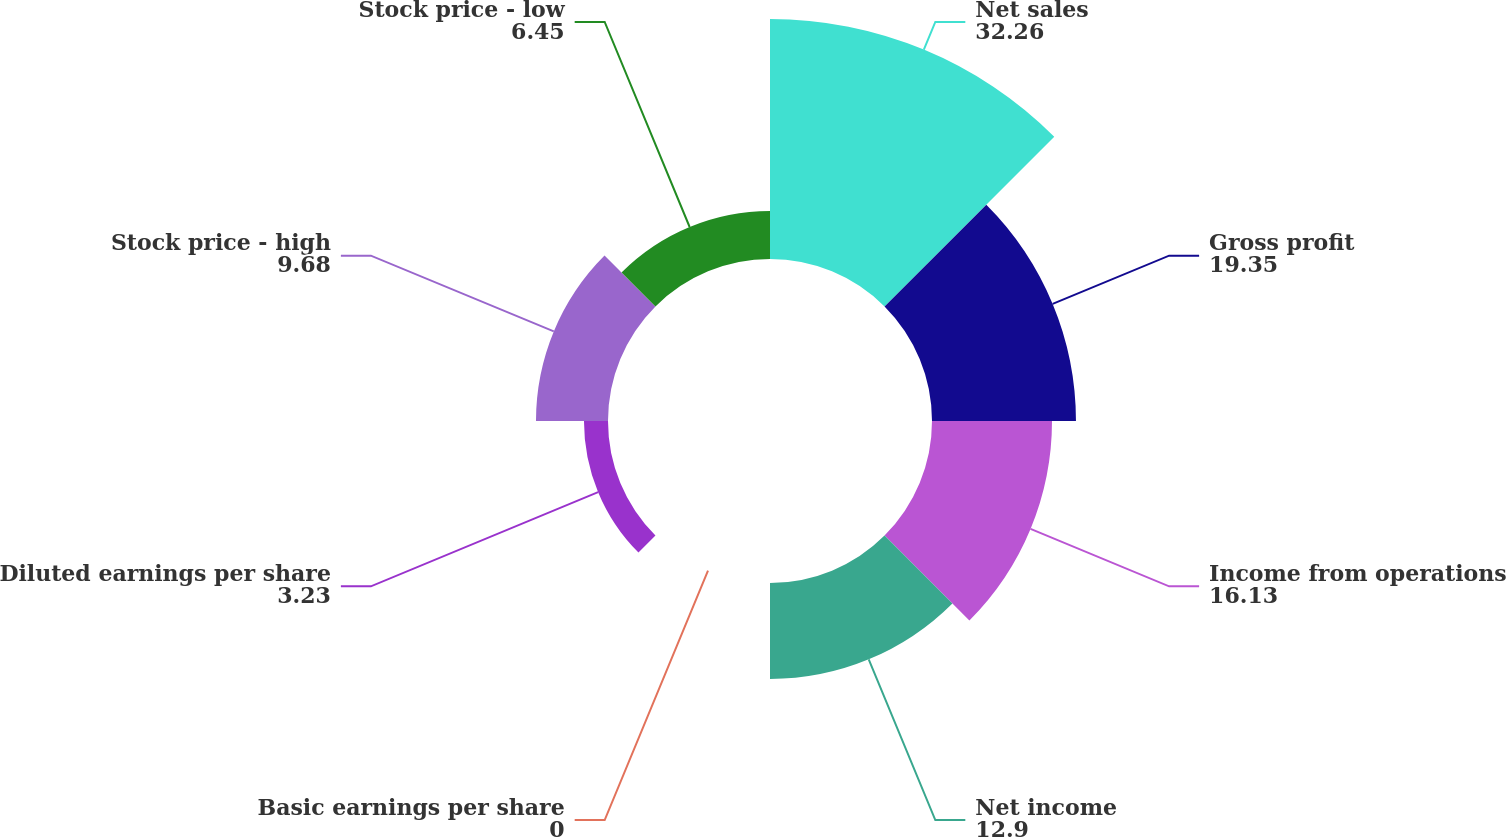Convert chart to OTSL. <chart><loc_0><loc_0><loc_500><loc_500><pie_chart><fcel>Net sales<fcel>Gross profit<fcel>Income from operations<fcel>Net income<fcel>Basic earnings per share<fcel>Diluted earnings per share<fcel>Stock price - high<fcel>Stock price - low<nl><fcel>32.26%<fcel>19.35%<fcel>16.13%<fcel>12.9%<fcel>0.0%<fcel>3.23%<fcel>9.68%<fcel>6.45%<nl></chart> 